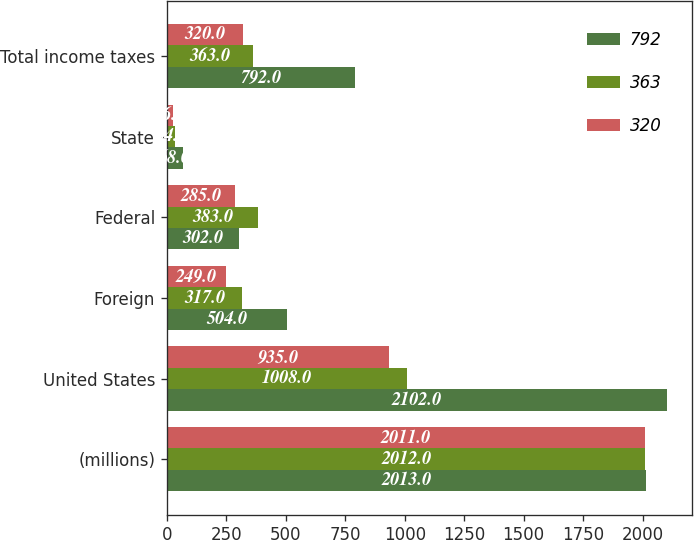Convert chart. <chart><loc_0><loc_0><loc_500><loc_500><stacked_bar_chart><ecel><fcel>(millions)<fcel>United States<fcel>Foreign<fcel>Federal<fcel>State<fcel>Total income taxes<nl><fcel>792<fcel>2013<fcel>2102<fcel>504<fcel>302<fcel>68<fcel>792<nl><fcel>363<fcel>2012<fcel>1008<fcel>317<fcel>383<fcel>34<fcel>363<nl><fcel>320<fcel>2011<fcel>935<fcel>249<fcel>285<fcel>26<fcel>320<nl></chart> 